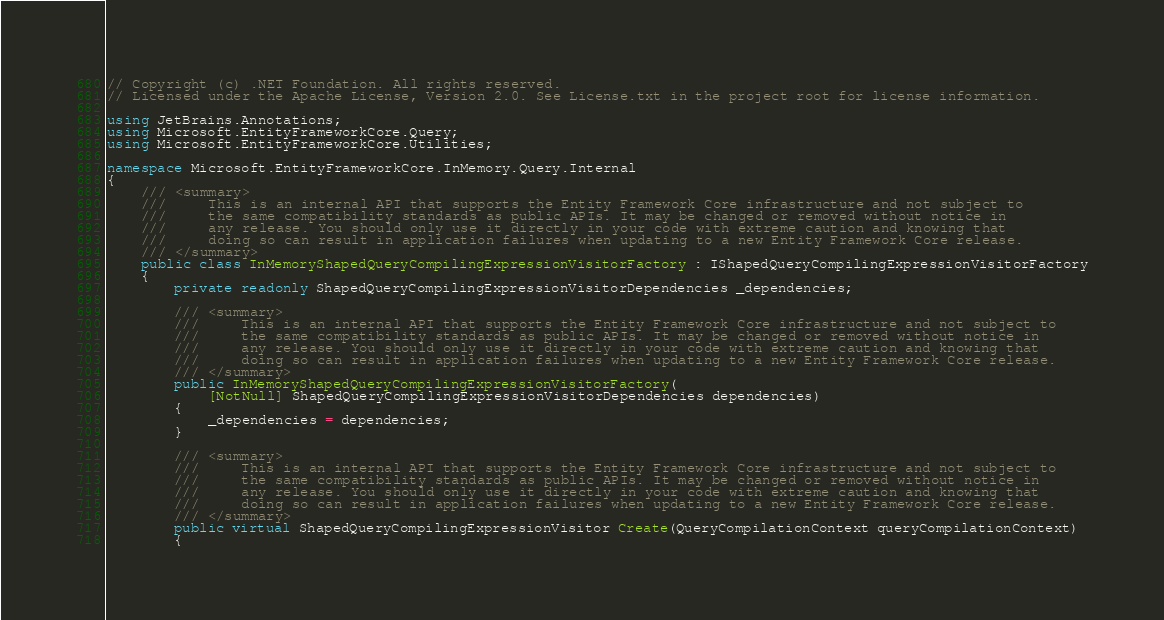<code> <loc_0><loc_0><loc_500><loc_500><_C#_>// Copyright (c) .NET Foundation. All rights reserved.
// Licensed under the Apache License, Version 2.0. See License.txt in the project root for license information.

using JetBrains.Annotations;
using Microsoft.EntityFrameworkCore.Query;
using Microsoft.EntityFrameworkCore.Utilities;

namespace Microsoft.EntityFrameworkCore.InMemory.Query.Internal
{
    /// <summary>
    ///     This is an internal API that supports the Entity Framework Core infrastructure and not subject to
    ///     the same compatibility standards as public APIs. It may be changed or removed without notice in
    ///     any release. You should only use it directly in your code with extreme caution and knowing that
    ///     doing so can result in application failures when updating to a new Entity Framework Core release.
    /// </summary>
    public class InMemoryShapedQueryCompilingExpressionVisitorFactory : IShapedQueryCompilingExpressionVisitorFactory
    {
        private readonly ShapedQueryCompilingExpressionVisitorDependencies _dependencies;

        /// <summary>
        ///     This is an internal API that supports the Entity Framework Core infrastructure and not subject to
        ///     the same compatibility standards as public APIs. It may be changed or removed without notice in
        ///     any release. You should only use it directly in your code with extreme caution and knowing that
        ///     doing so can result in application failures when updating to a new Entity Framework Core release.
        /// </summary>
        public InMemoryShapedQueryCompilingExpressionVisitorFactory(
            [NotNull] ShapedQueryCompilingExpressionVisitorDependencies dependencies)
        {
            _dependencies = dependencies;
        }

        /// <summary>
        ///     This is an internal API that supports the Entity Framework Core infrastructure and not subject to
        ///     the same compatibility standards as public APIs. It may be changed or removed without notice in
        ///     any release. You should only use it directly in your code with extreme caution and knowing that
        ///     doing so can result in application failures when updating to a new Entity Framework Core release.
        /// </summary>
        public virtual ShapedQueryCompilingExpressionVisitor Create(QueryCompilationContext queryCompilationContext)
        {</code> 